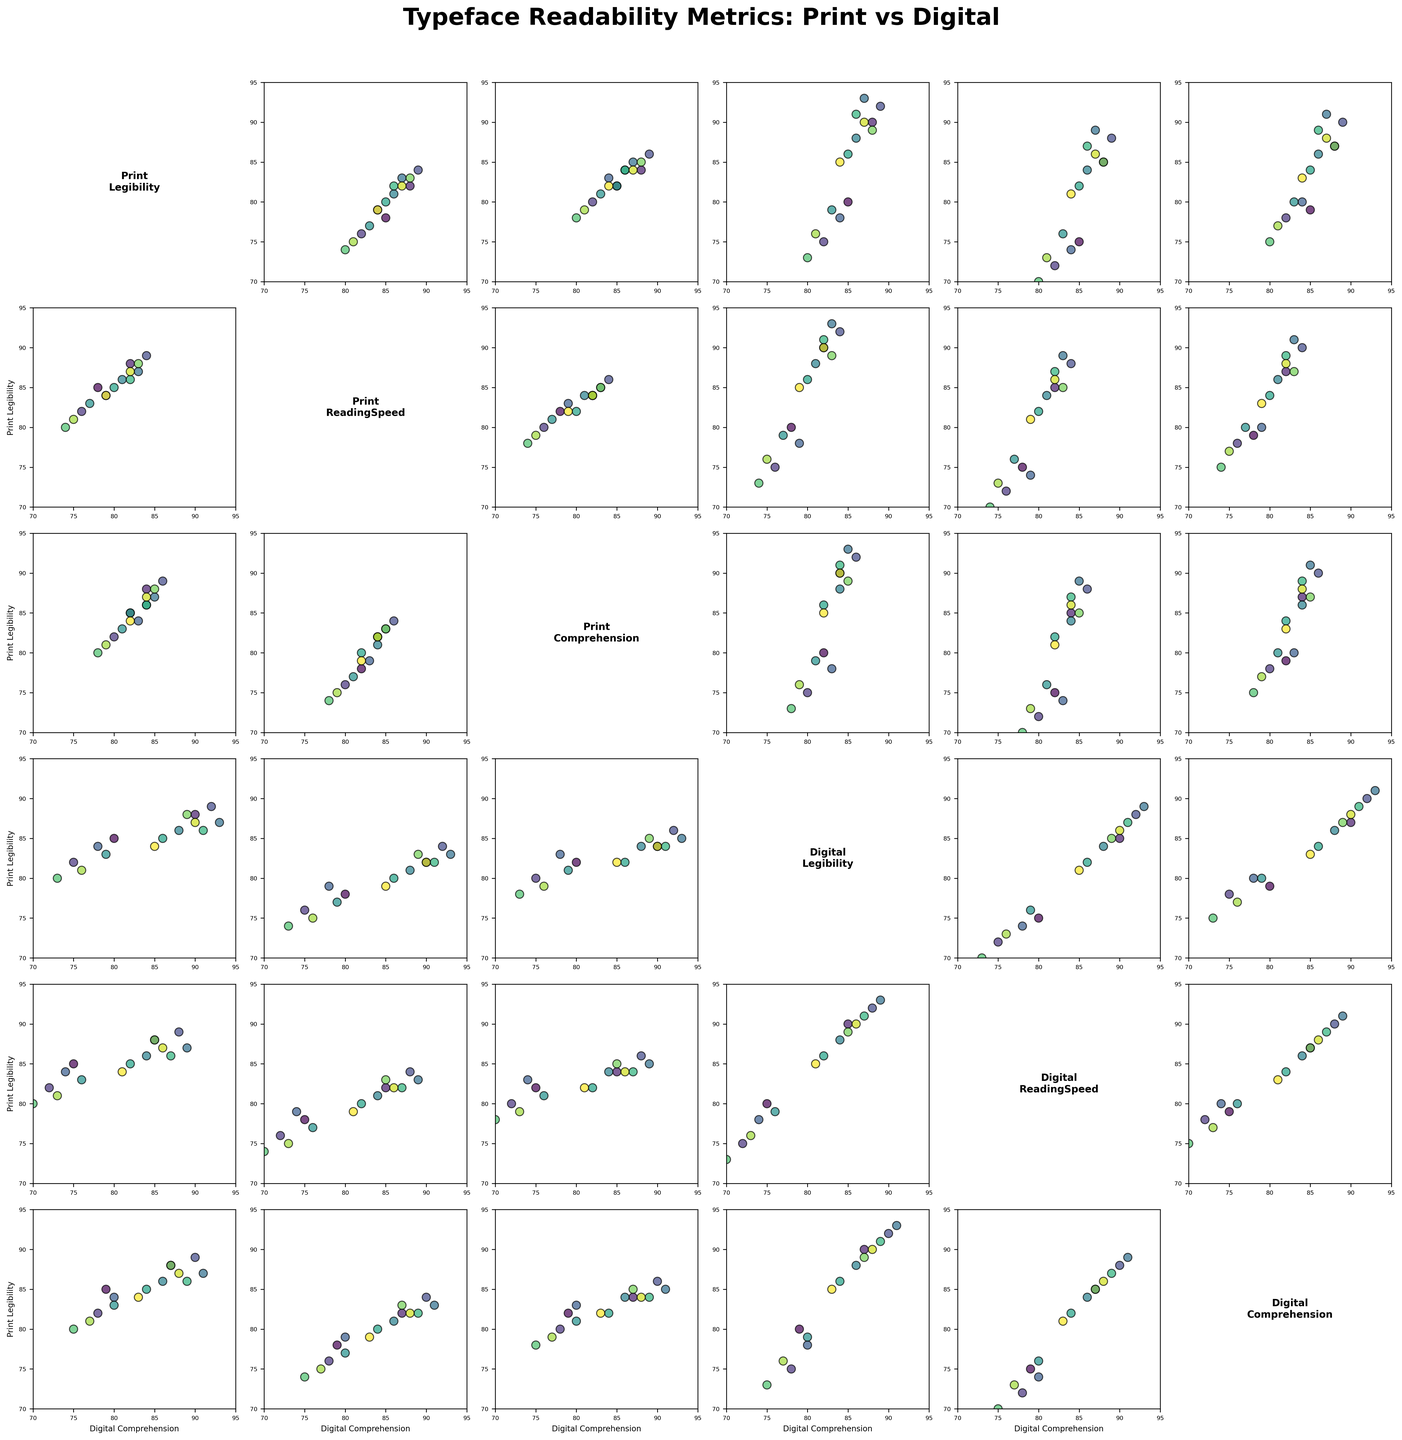What is the title of this figure? The figure's title is located at the top of the plot, indicating the main subject of the figure. The title reads "Typeface Readability Metrics: Print vs Digital."
Answer: Typeface Readability Metrics: Print vs Digital How many typefaces are compared in this figure? By counting the number of points appearing in any scatter plot within the scatterplot matrix, we can determine the number of typefaces. There are 15 points, corresponding to 15 typefaces.
Answer: 15 Which metric pair shows the highest correlation in digital media? Look for the scatter plot where the points form a pattern closest to a straight line among the Digital metrics (Digital_Legibility, Digital_ReadingSpeed, Digital_Comprehension). The plot of Digital_Legibility vs. Digital_ReadingSpeed shows a strong linear trend.
Answer: Digital_Legibility vs. Digital_ReadingSpeed Do any metrics have perfectly equal values across all typefaces? Look along the diagonal plots for any notation of a perfect vertical line representing one value throughout or compare scatter plots. There are no perfectly equal values for any metric combinations visible in the scatterplot matrix.
Answer: No How does the legibility of Times New Roman in print compare to its legibility in digital media? Find the Times New Roman points on the scatter plots related to legibility. Times New Roman has a print legibility of 85 and a digital legibility of 80.
Answer: Print legibility is higher than digital Identify the typeface with the highest digital reading speed. Check the scatter plots involving Digital_ReadingSpeed and find the point with the maximum value on the Digital_ReadingSpeed axis. In the matrix, this corresponds to Verdana which has a digital reading speed of 89.
Answer: Verdana Which typeface has the lowest overall comprehension score, considering both print and digital? For each typeface, sum the Print_Comprehension and Digital_Comprehension scores, then identify the typeface with the minimum combined score. Bodoni has the lowest total comprehension score (Print_78 + Digital_75 = 153).
Answer: Bodoni Which typeface shows the greatest difference in legibility between print and digital formats? Calculate the absolute differences between Print_Legibility and Digital_Legibility for each typeface, then identify the maximum difference. Garamond has the greatest difference (82 - 75 = 7).
Answer: Garamond Is there any typeface that has roughly the same reading speed in both print and digital formats? Look for typefaces where the values of Print_ReadingSpeed and Digital_ReadingSpeed are very close. Arial has roughly the same reading speeds of 82 in print and 85 in digital, showing a small difference of 3.
Answer: Arial For Frutiger, is the reading speed higher in print or digital format? Find the Frutiger data points on the scatter plots related to reading speed. Frutiger has a print reading speed of 83 and a digital reading speed of 85.
Answer: Digital 